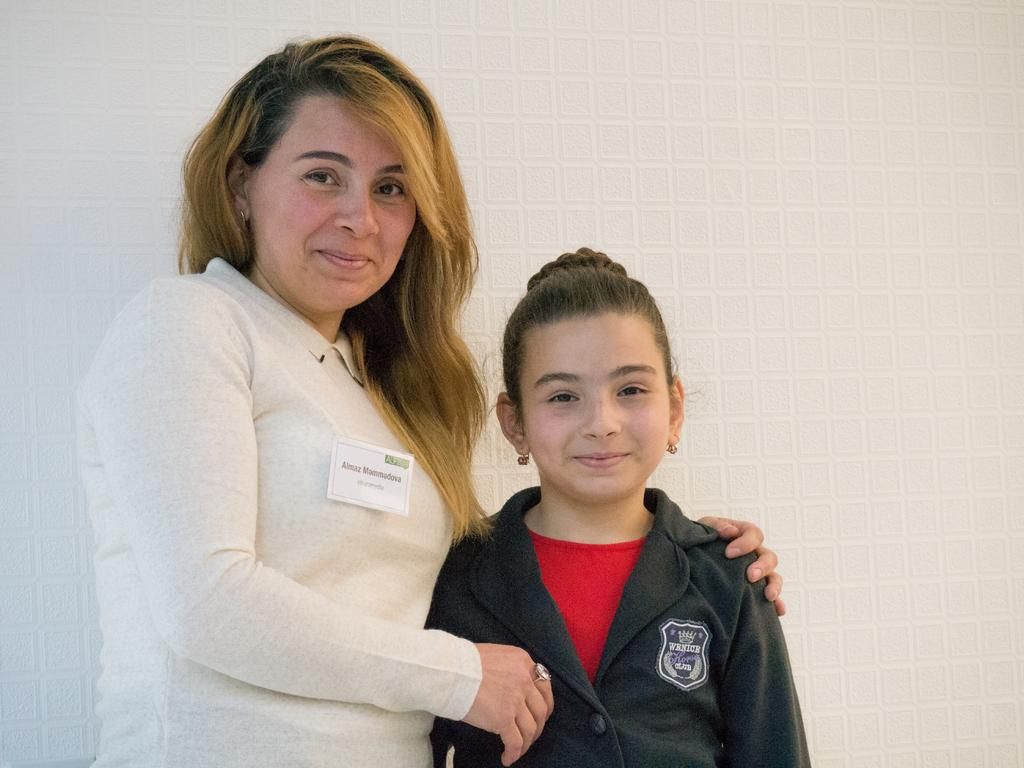How many people are in the image? There are two persons in the image. What are the persons doing in the image? The persons are standing and smiling. What can be seen in the background of the image? There is a wall in the background of the image. What type of debt is being discussed by the persons in the image? There is no indication in the image that the persons are discussing debt, as they are standing and smiling. 